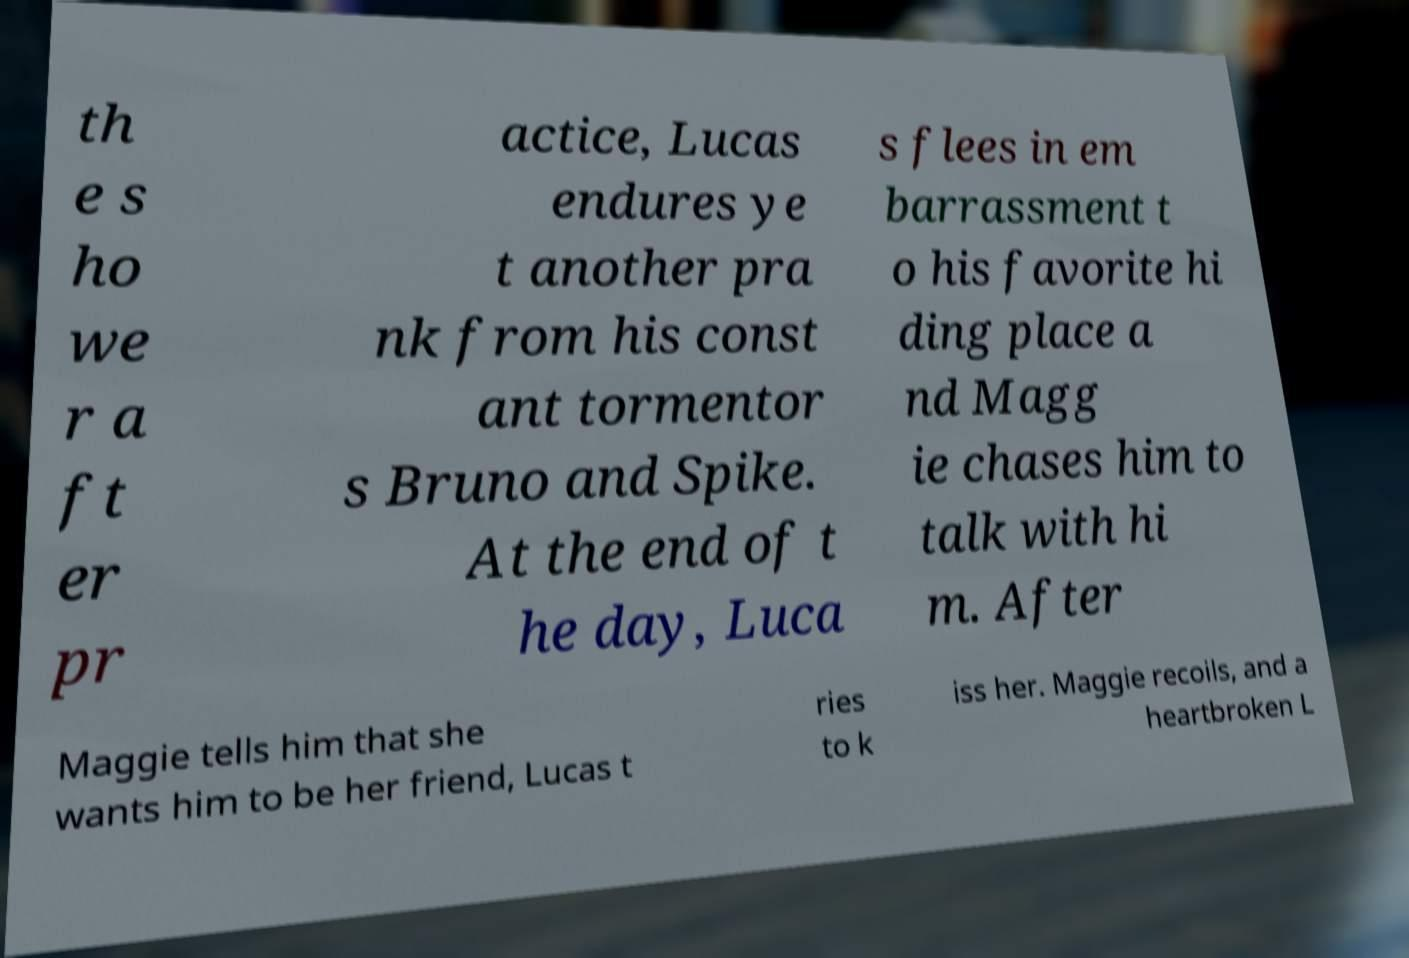There's text embedded in this image that I need extracted. Can you transcribe it verbatim? th e s ho we r a ft er pr actice, Lucas endures ye t another pra nk from his const ant tormentor s Bruno and Spike. At the end of t he day, Luca s flees in em barrassment t o his favorite hi ding place a nd Magg ie chases him to talk with hi m. After Maggie tells him that she wants him to be her friend, Lucas t ries to k iss her. Maggie recoils, and a heartbroken L 